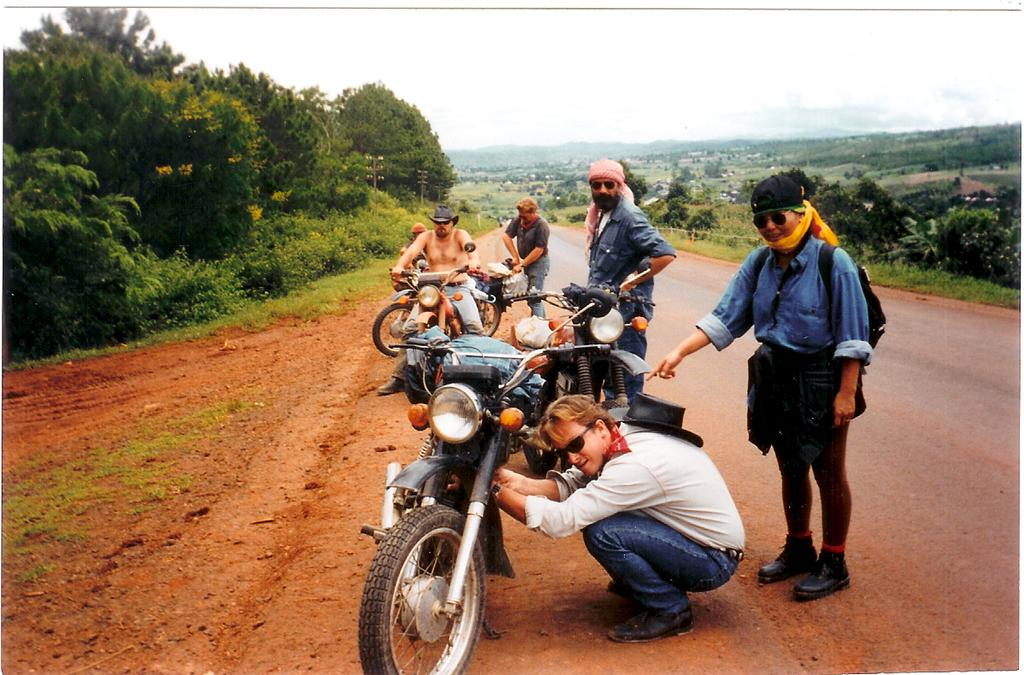What is the main subject of the image? There is a man on a motorcycle in the image. How many people are present in the image? There are three people standing in the image. What is the person on the right side of the image doing? A person is holding a motorcycle with their hands. What type of natural environment can be seen in the image? There are trees visible in the image. What type of sheet is draped over the motorcycle in the image? There is no sheet present in the image; the motorcycle is being held by a person's hands. 